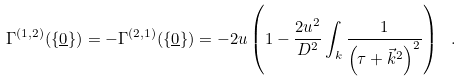<formula> <loc_0><loc_0><loc_500><loc_500>\Gamma ^ { ( 1 , 2 ) } ( \{ { \underline { 0 } } \} ) = - \Gamma ^ { ( 2 , 1 ) } ( \{ { \underline { 0 } } \} ) = - 2 u \left ( 1 - \frac { 2 u ^ { 2 } } { D ^ { 2 } } \int _ { k } \frac { 1 } { \left ( \tau + \vec { k } ^ { 2 } \right ) ^ { 2 } } \right ) \ .</formula> 